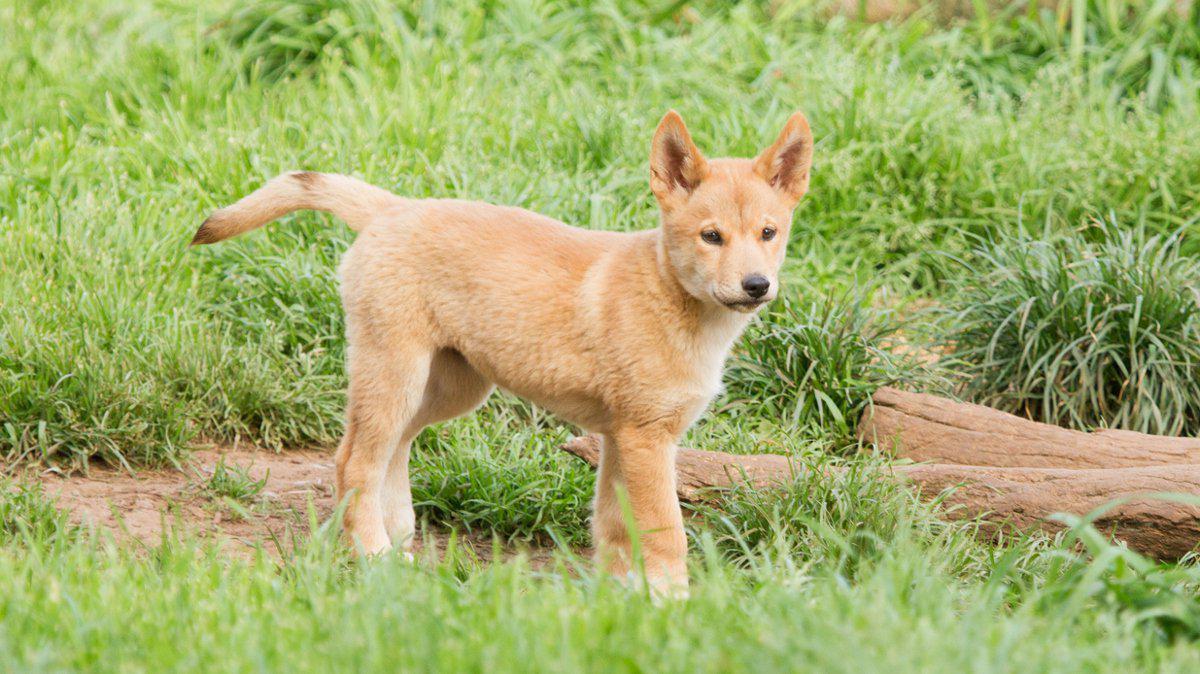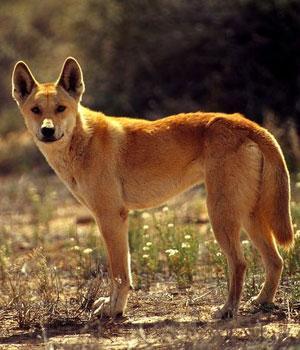The first image is the image on the left, the second image is the image on the right. For the images displayed, is the sentence "Only one dog has its mouth open." factually correct? Answer yes or no. No. The first image is the image on the left, the second image is the image on the right. For the images shown, is this caption "A dog is standing on all fours on something made of cement." true? Answer yes or no. No. 